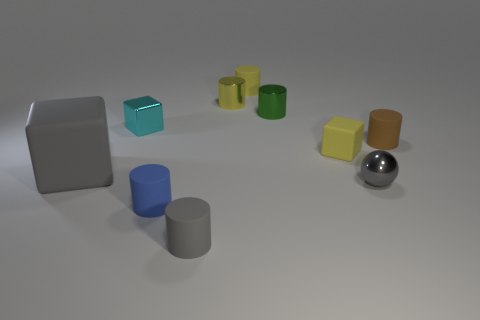Subtract all small blue matte cylinders. How many cylinders are left? 5 Subtract all brown cylinders. How many cylinders are left? 5 Subtract 0 purple blocks. How many objects are left? 10 Subtract all cubes. How many objects are left? 7 Subtract 5 cylinders. How many cylinders are left? 1 Subtract all blue cylinders. Subtract all green spheres. How many cylinders are left? 5 Subtract all blue cubes. How many brown cylinders are left? 1 Subtract all yellow metallic objects. Subtract all brown objects. How many objects are left? 8 Add 5 brown cylinders. How many brown cylinders are left? 6 Add 10 red shiny cylinders. How many red shiny cylinders exist? 10 